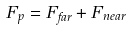Convert formula to latex. <formula><loc_0><loc_0><loc_500><loc_500>F _ { p } = F _ { f a r } + F _ { n e a r }</formula> 